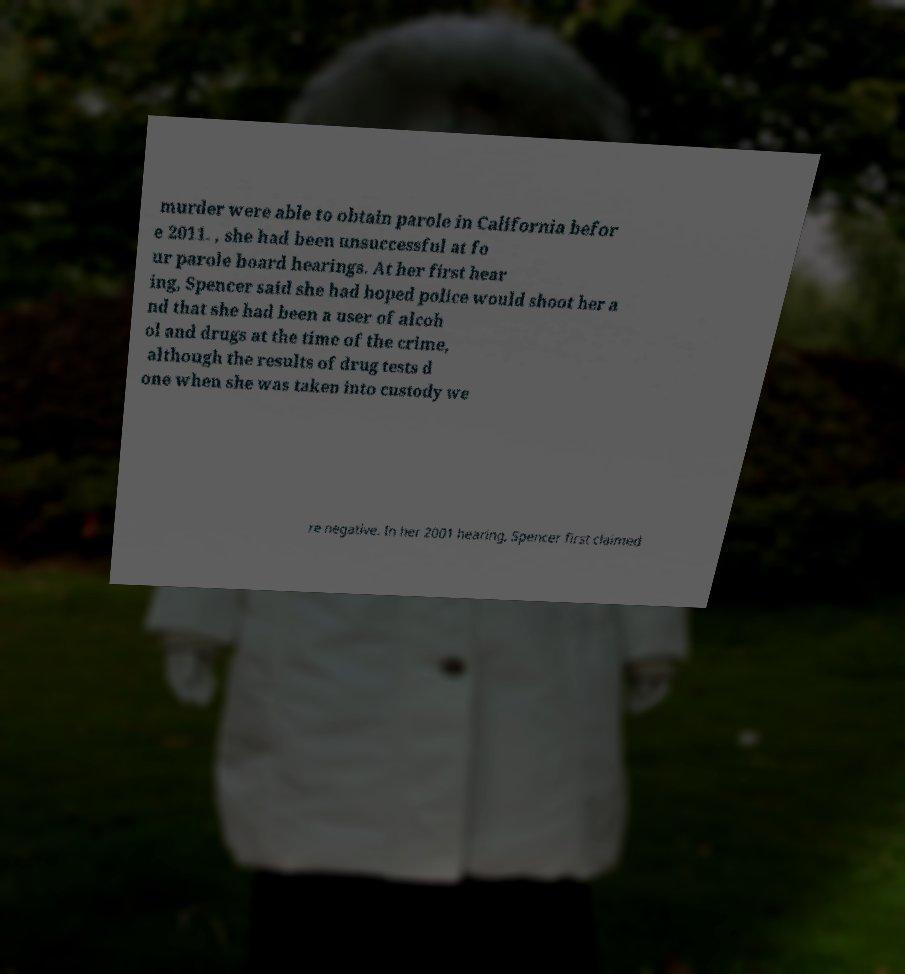Please read and relay the text visible in this image. What does it say? murder were able to obtain parole in California befor e 2011. , she had been unsuccessful at fo ur parole board hearings. At her first hear ing, Spencer said she had hoped police would shoot her a nd that she had been a user of alcoh ol and drugs at the time of the crime, although the results of drug tests d one when she was taken into custody we re negative. In her 2001 hearing, Spencer first claimed 